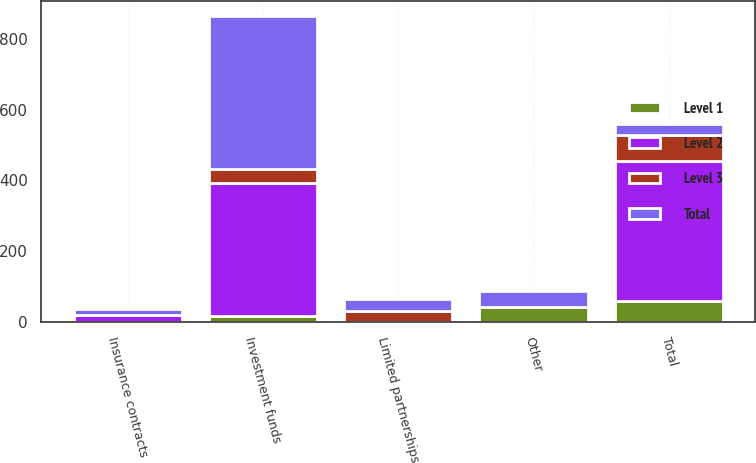<chart> <loc_0><loc_0><loc_500><loc_500><stacked_bar_chart><ecel><fcel>Investment funds<fcel>Insurance contracts<fcel>Limited partnerships<fcel>Other<fcel>Total<nl><fcel>Level 1<fcel>18.8<fcel>0<fcel>0<fcel>42.4<fcel>61.2<nl><fcel>Level 2<fcel>372.6<fcel>19.3<fcel>0<fcel>1.4<fcel>393.3<nl><fcel>Level 3<fcel>40.1<fcel>0<fcel>32.1<fcel>0.3<fcel>72.5<nl><fcel>Total<fcel>431.5<fcel>19.3<fcel>32.1<fcel>44.1<fcel>32.1<nl></chart> 